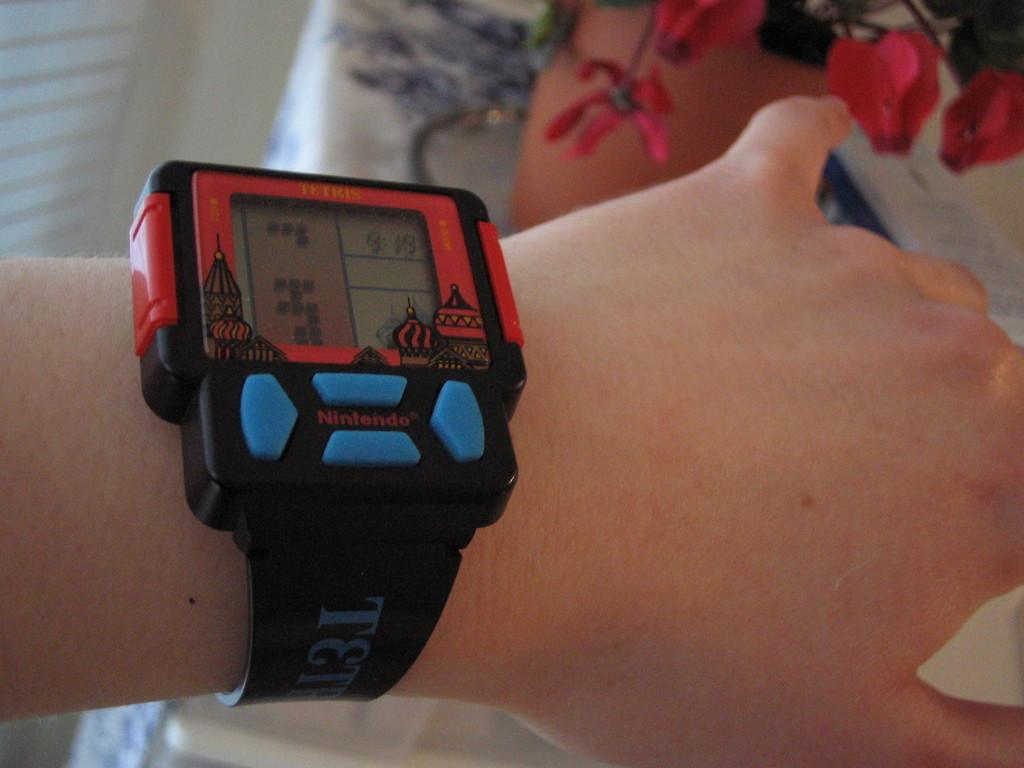<image>
Share a concise interpretation of the image provided. A person has a wearable Nintendo video game watch on them. 